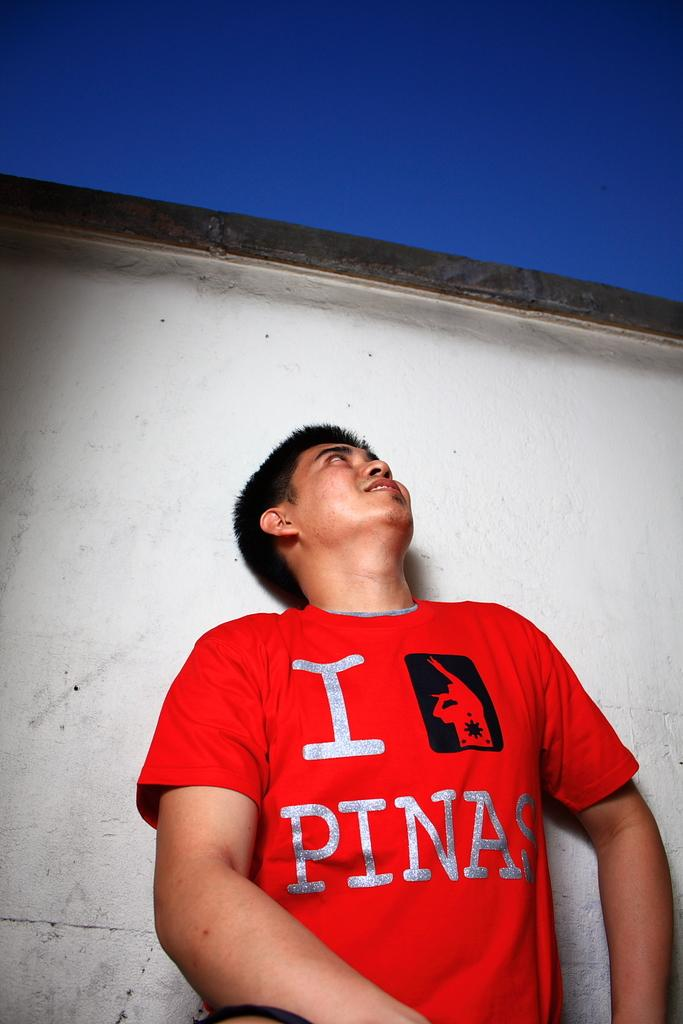<image>
Write a terse but informative summary of the picture. A man is looking up into the sky and wearing a red shirt that says I pinas. 